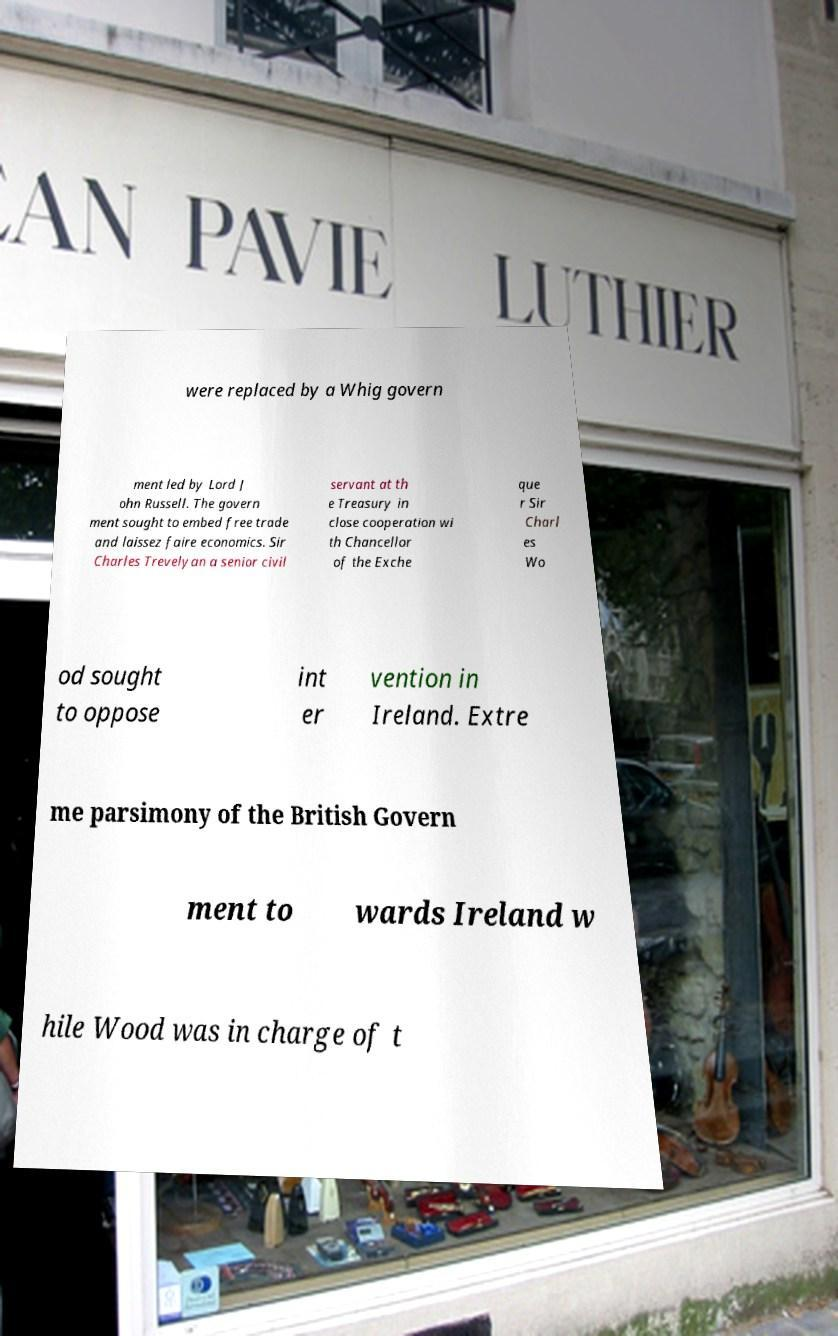Please read and relay the text visible in this image. What does it say? were replaced by a Whig govern ment led by Lord J ohn Russell. The govern ment sought to embed free trade and laissez faire economics. Sir Charles Trevelyan a senior civil servant at th e Treasury in close cooperation wi th Chancellor of the Exche que r Sir Charl es Wo od sought to oppose int er vention in Ireland. Extre me parsimony of the British Govern ment to wards Ireland w hile Wood was in charge of t 